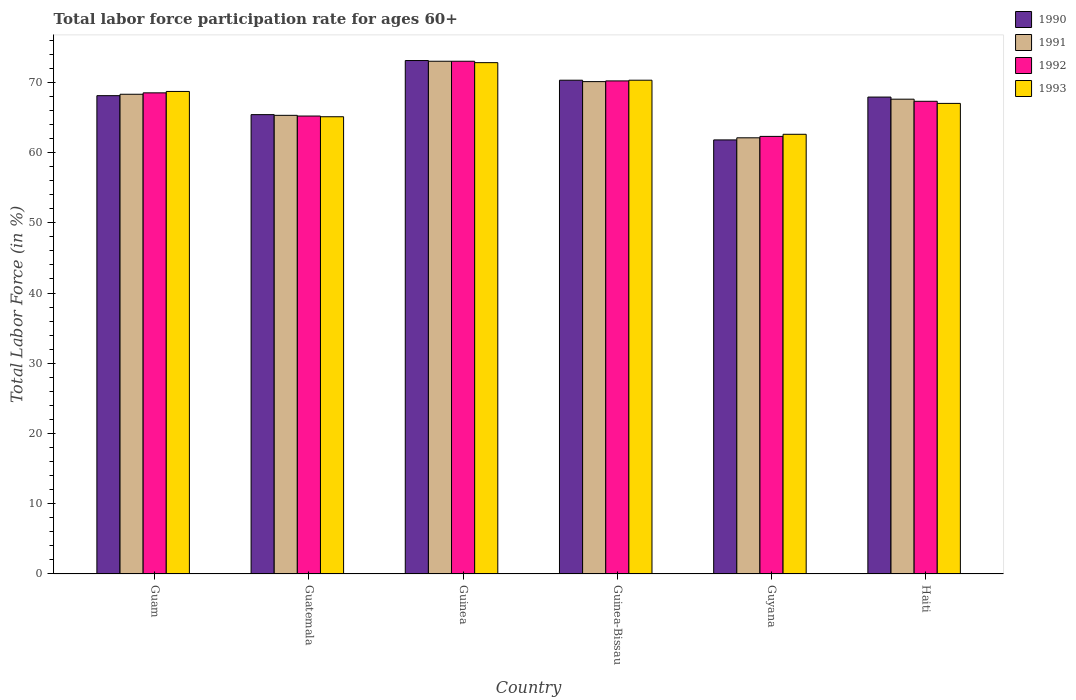How many groups of bars are there?
Your answer should be compact. 6. Are the number of bars on each tick of the X-axis equal?
Ensure brevity in your answer.  Yes. How many bars are there on the 6th tick from the left?
Provide a short and direct response. 4. How many bars are there on the 3rd tick from the right?
Your response must be concise. 4. What is the label of the 2nd group of bars from the left?
Your answer should be compact. Guatemala. What is the labor force participation rate in 1990 in Guyana?
Provide a succinct answer. 61.8. Across all countries, what is the minimum labor force participation rate in 1993?
Your answer should be very brief. 62.6. In which country was the labor force participation rate in 1991 maximum?
Your answer should be very brief. Guinea. In which country was the labor force participation rate in 1993 minimum?
Offer a terse response. Guyana. What is the total labor force participation rate in 1993 in the graph?
Your answer should be very brief. 406.5. What is the difference between the labor force participation rate in 1990 in Guatemala and that in Guyana?
Your answer should be compact. 3.6. What is the difference between the labor force participation rate in 1993 in Guyana and the labor force participation rate in 1990 in Guinea-Bissau?
Make the answer very short. -7.7. What is the average labor force participation rate in 1992 per country?
Your response must be concise. 67.75. What is the difference between the labor force participation rate of/in 1993 and labor force participation rate of/in 1991 in Guam?
Provide a short and direct response. 0.4. What is the ratio of the labor force participation rate in 1990 in Guam to that in Guatemala?
Provide a short and direct response. 1.04. Is the labor force participation rate in 1992 in Guatemala less than that in Guinea-Bissau?
Offer a terse response. Yes. Is the difference between the labor force participation rate in 1993 in Guam and Guatemala greater than the difference between the labor force participation rate in 1991 in Guam and Guatemala?
Provide a short and direct response. Yes. What is the difference between the highest and the second highest labor force participation rate in 1993?
Your answer should be compact. 4.1. What is the difference between the highest and the lowest labor force participation rate in 1992?
Offer a very short reply. 10.7. Is the sum of the labor force participation rate in 1990 in Guinea and Guinea-Bissau greater than the maximum labor force participation rate in 1991 across all countries?
Your answer should be very brief. Yes. Is it the case that in every country, the sum of the labor force participation rate in 1993 and labor force participation rate in 1991 is greater than the sum of labor force participation rate in 1990 and labor force participation rate in 1992?
Keep it short and to the point. No. What does the 4th bar from the left in Guam represents?
Ensure brevity in your answer.  1993. What does the 2nd bar from the right in Guyana represents?
Your response must be concise. 1992. Is it the case that in every country, the sum of the labor force participation rate in 1992 and labor force participation rate in 1991 is greater than the labor force participation rate in 1993?
Provide a succinct answer. Yes. How many bars are there?
Provide a short and direct response. 24. Are all the bars in the graph horizontal?
Your answer should be very brief. No. How many countries are there in the graph?
Provide a short and direct response. 6. What is the difference between two consecutive major ticks on the Y-axis?
Provide a short and direct response. 10. Where does the legend appear in the graph?
Make the answer very short. Top right. How many legend labels are there?
Make the answer very short. 4. What is the title of the graph?
Ensure brevity in your answer.  Total labor force participation rate for ages 60+. Does "1975" appear as one of the legend labels in the graph?
Give a very brief answer. No. What is the label or title of the Y-axis?
Make the answer very short. Total Labor Force (in %). What is the Total Labor Force (in %) of 1990 in Guam?
Keep it short and to the point. 68.1. What is the Total Labor Force (in %) of 1991 in Guam?
Provide a short and direct response. 68.3. What is the Total Labor Force (in %) of 1992 in Guam?
Your response must be concise. 68.5. What is the Total Labor Force (in %) in 1993 in Guam?
Provide a short and direct response. 68.7. What is the Total Labor Force (in %) of 1990 in Guatemala?
Keep it short and to the point. 65.4. What is the Total Labor Force (in %) in 1991 in Guatemala?
Keep it short and to the point. 65.3. What is the Total Labor Force (in %) in 1992 in Guatemala?
Offer a terse response. 65.2. What is the Total Labor Force (in %) in 1993 in Guatemala?
Give a very brief answer. 65.1. What is the Total Labor Force (in %) of 1990 in Guinea?
Your answer should be compact. 73.1. What is the Total Labor Force (in %) of 1991 in Guinea?
Provide a short and direct response. 73. What is the Total Labor Force (in %) in 1993 in Guinea?
Your answer should be compact. 72.8. What is the Total Labor Force (in %) in 1990 in Guinea-Bissau?
Provide a short and direct response. 70.3. What is the Total Labor Force (in %) in 1991 in Guinea-Bissau?
Offer a terse response. 70.1. What is the Total Labor Force (in %) of 1992 in Guinea-Bissau?
Offer a terse response. 70.2. What is the Total Labor Force (in %) in 1993 in Guinea-Bissau?
Offer a very short reply. 70.3. What is the Total Labor Force (in %) in 1990 in Guyana?
Offer a terse response. 61.8. What is the Total Labor Force (in %) of 1991 in Guyana?
Offer a very short reply. 62.1. What is the Total Labor Force (in %) in 1992 in Guyana?
Keep it short and to the point. 62.3. What is the Total Labor Force (in %) of 1993 in Guyana?
Your answer should be very brief. 62.6. What is the Total Labor Force (in %) of 1990 in Haiti?
Offer a terse response. 67.9. What is the Total Labor Force (in %) of 1991 in Haiti?
Provide a short and direct response. 67.6. What is the Total Labor Force (in %) in 1992 in Haiti?
Make the answer very short. 67.3. Across all countries, what is the maximum Total Labor Force (in %) in 1990?
Provide a succinct answer. 73.1. Across all countries, what is the maximum Total Labor Force (in %) of 1991?
Offer a terse response. 73. Across all countries, what is the maximum Total Labor Force (in %) in 1992?
Make the answer very short. 73. Across all countries, what is the maximum Total Labor Force (in %) of 1993?
Give a very brief answer. 72.8. Across all countries, what is the minimum Total Labor Force (in %) in 1990?
Make the answer very short. 61.8. Across all countries, what is the minimum Total Labor Force (in %) of 1991?
Give a very brief answer. 62.1. Across all countries, what is the minimum Total Labor Force (in %) in 1992?
Your response must be concise. 62.3. Across all countries, what is the minimum Total Labor Force (in %) in 1993?
Offer a terse response. 62.6. What is the total Total Labor Force (in %) in 1990 in the graph?
Offer a terse response. 406.6. What is the total Total Labor Force (in %) in 1991 in the graph?
Give a very brief answer. 406.4. What is the total Total Labor Force (in %) in 1992 in the graph?
Make the answer very short. 406.5. What is the total Total Labor Force (in %) of 1993 in the graph?
Ensure brevity in your answer.  406.5. What is the difference between the Total Labor Force (in %) of 1991 in Guam and that in Guatemala?
Provide a short and direct response. 3. What is the difference between the Total Labor Force (in %) in 1993 in Guam and that in Guatemala?
Your answer should be compact. 3.6. What is the difference between the Total Labor Force (in %) of 1991 in Guam and that in Guinea-Bissau?
Your answer should be compact. -1.8. What is the difference between the Total Labor Force (in %) of 1991 in Guam and that in Guyana?
Provide a short and direct response. 6.2. What is the difference between the Total Labor Force (in %) of 1993 in Guam and that in Guyana?
Provide a succinct answer. 6.1. What is the difference between the Total Labor Force (in %) of 1990 in Guam and that in Haiti?
Ensure brevity in your answer.  0.2. What is the difference between the Total Labor Force (in %) of 1991 in Guam and that in Haiti?
Your answer should be very brief. 0.7. What is the difference between the Total Labor Force (in %) in 1993 in Guam and that in Haiti?
Keep it short and to the point. 1.7. What is the difference between the Total Labor Force (in %) of 1990 in Guatemala and that in Guinea?
Keep it short and to the point. -7.7. What is the difference between the Total Labor Force (in %) in 1993 in Guatemala and that in Guinea?
Ensure brevity in your answer.  -7.7. What is the difference between the Total Labor Force (in %) of 1990 in Guatemala and that in Guinea-Bissau?
Provide a succinct answer. -4.9. What is the difference between the Total Labor Force (in %) in 1991 in Guatemala and that in Guinea-Bissau?
Provide a succinct answer. -4.8. What is the difference between the Total Labor Force (in %) of 1992 in Guatemala and that in Guinea-Bissau?
Provide a succinct answer. -5. What is the difference between the Total Labor Force (in %) in 1993 in Guatemala and that in Guinea-Bissau?
Offer a terse response. -5.2. What is the difference between the Total Labor Force (in %) of 1990 in Guatemala and that in Guyana?
Keep it short and to the point. 3.6. What is the difference between the Total Labor Force (in %) of 1993 in Guatemala and that in Guyana?
Your answer should be very brief. 2.5. What is the difference between the Total Labor Force (in %) of 1990 in Guinea and that in Guinea-Bissau?
Provide a succinct answer. 2.8. What is the difference between the Total Labor Force (in %) of 1992 in Guinea and that in Guinea-Bissau?
Provide a succinct answer. 2.8. What is the difference between the Total Labor Force (in %) in 1993 in Guinea and that in Guinea-Bissau?
Provide a short and direct response. 2.5. What is the difference between the Total Labor Force (in %) of 1990 in Guinea and that in Guyana?
Make the answer very short. 11.3. What is the difference between the Total Labor Force (in %) of 1990 in Guinea and that in Haiti?
Your answer should be very brief. 5.2. What is the difference between the Total Labor Force (in %) in 1990 in Guinea-Bissau and that in Guyana?
Give a very brief answer. 8.5. What is the difference between the Total Labor Force (in %) in 1993 in Guinea-Bissau and that in Guyana?
Provide a succinct answer. 7.7. What is the difference between the Total Labor Force (in %) of 1990 in Guinea-Bissau and that in Haiti?
Keep it short and to the point. 2.4. What is the difference between the Total Labor Force (in %) of 1991 in Guyana and that in Haiti?
Provide a succinct answer. -5.5. What is the difference between the Total Labor Force (in %) in 1992 in Guam and the Total Labor Force (in %) in 1993 in Guatemala?
Offer a very short reply. 3.4. What is the difference between the Total Labor Force (in %) in 1990 in Guam and the Total Labor Force (in %) in 1991 in Guinea?
Provide a succinct answer. -4.9. What is the difference between the Total Labor Force (in %) in 1992 in Guam and the Total Labor Force (in %) in 1993 in Guinea-Bissau?
Make the answer very short. -1.8. What is the difference between the Total Labor Force (in %) in 1990 in Guam and the Total Labor Force (in %) in 1991 in Guyana?
Offer a terse response. 6. What is the difference between the Total Labor Force (in %) of 1990 in Guam and the Total Labor Force (in %) of 1993 in Guyana?
Your answer should be compact. 5.5. What is the difference between the Total Labor Force (in %) in 1991 in Guam and the Total Labor Force (in %) in 1992 in Guyana?
Your answer should be compact. 6. What is the difference between the Total Labor Force (in %) of 1991 in Guam and the Total Labor Force (in %) of 1993 in Guyana?
Keep it short and to the point. 5.7. What is the difference between the Total Labor Force (in %) of 1990 in Guam and the Total Labor Force (in %) of 1991 in Haiti?
Your answer should be compact. 0.5. What is the difference between the Total Labor Force (in %) of 1990 in Guam and the Total Labor Force (in %) of 1992 in Haiti?
Your answer should be very brief. 0.8. What is the difference between the Total Labor Force (in %) of 1990 in Guam and the Total Labor Force (in %) of 1993 in Haiti?
Keep it short and to the point. 1.1. What is the difference between the Total Labor Force (in %) of 1991 in Guam and the Total Labor Force (in %) of 1992 in Haiti?
Offer a very short reply. 1. What is the difference between the Total Labor Force (in %) in 1991 in Guam and the Total Labor Force (in %) in 1993 in Haiti?
Make the answer very short. 1.3. What is the difference between the Total Labor Force (in %) in 1992 in Guam and the Total Labor Force (in %) in 1993 in Haiti?
Your answer should be compact. 1.5. What is the difference between the Total Labor Force (in %) in 1991 in Guatemala and the Total Labor Force (in %) in 1992 in Guinea-Bissau?
Make the answer very short. -4.9. What is the difference between the Total Labor Force (in %) of 1992 in Guatemala and the Total Labor Force (in %) of 1993 in Guinea-Bissau?
Offer a terse response. -5.1. What is the difference between the Total Labor Force (in %) of 1990 in Guatemala and the Total Labor Force (in %) of 1991 in Guyana?
Keep it short and to the point. 3.3. What is the difference between the Total Labor Force (in %) in 1990 in Guatemala and the Total Labor Force (in %) in 1992 in Guyana?
Ensure brevity in your answer.  3.1. What is the difference between the Total Labor Force (in %) of 1990 in Guatemala and the Total Labor Force (in %) of 1993 in Guyana?
Ensure brevity in your answer.  2.8. What is the difference between the Total Labor Force (in %) in 1990 in Guatemala and the Total Labor Force (in %) in 1992 in Haiti?
Give a very brief answer. -1.9. What is the difference between the Total Labor Force (in %) in 1990 in Guatemala and the Total Labor Force (in %) in 1993 in Haiti?
Your answer should be compact. -1.6. What is the difference between the Total Labor Force (in %) of 1991 in Guatemala and the Total Labor Force (in %) of 1993 in Haiti?
Keep it short and to the point. -1.7. What is the difference between the Total Labor Force (in %) in 1990 in Guinea and the Total Labor Force (in %) in 1992 in Guinea-Bissau?
Give a very brief answer. 2.9. What is the difference between the Total Labor Force (in %) of 1992 in Guinea and the Total Labor Force (in %) of 1993 in Guinea-Bissau?
Offer a terse response. 2.7. What is the difference between the Total Labor Force (in %) in 1990 in Guinea and the Total Labor Force (in %) in 1991 in Guyana?
Keep it short and to the point. 11. What is the difference between the Total Labor Force (in %) in 1990 in Guinea and the Total Labor Force (in %) in 1993 in Guyana?
Ensure brevity in your answer.  10.5. What is the difference between the Total Labor Force (in %) in 1991 in Guinea and the Total Labor Force (in %) in 1992 in Guyana?
Your response must be concise. 10.7. What is the difference between the Total Labor Force (in %) in 1991 in Guinea and the Total Labor Force (in %) in 1993 in Guyana?
Ensure brevity in your answer.  10.4. What is the difference between the Total Labor Force (in %) in 1990 in Guinea and the Total Labor Force (in %) in 1991 in Haiti?
Keep it short and to the point. 5.5. What is the difference between the Total Labor Force (in %) of 1991 in Guinea and the Total Labor Force (in %) of 1993 in Haiti?
Offer a terse response. 6. What is the difference between the Total Labor Force (in %) of 1990 in Guyana and the Total Labor Force (in %) of 1991 in Haiti?
Your answer should be compact. -5.8. What is the difference between the Total Labor Force (in %) in 1990 in Guyana and the Total Labor Force (in %) in 1993 in Haiti?
Your response must be concise. -5.2. What is the difference between the Total Labor Force (in %) in 1991 in Guyana and the Total Labor Force (in %) in 1993 in Haiti?
Offer a terse response. -4.9. What is the difference between the Total Labor Force (in %) in 1992 in Guyana and the Total Labor Force (in %) in 1993 in Haiti?
Ensure brevity in your answer.  -4.7. What is the average Total Labor Force (in %) in 1990 per country?
Provide a short and direct response. 67.77. What is the average Total Labor Force (in %) in 1991 per country?
Your response must be concise. 67.73. What is the average Total Labor Force (in %) in 1992 per country?
Your response must be concise. 67.75. What is the average Total Labor Force (in %) in 1993 per country?
Your answer should be compact. 67.75. What is the difference between the Total Labor Force (in %) of 1990 and Total Labor Force (in %) of 1992 in Guam?
Offer a very short reply. -0.4. What is the difference between the Total Labor Force (in %) in 1991 and Total Labor Force (in %) in 1993 in Guam?
Make the answer very short. -0.4. What is the difference between the Total Labor Force (in %) in 1990 and Total Labor Force (in %) in 1991 in Guatemala?
Provide a succinct answer. 0.1. What is the difference between the Total Labor Force (in %) in 1990 and Total Labor Force (in %) in 1991 in Guinea?
Your answer should be very brief. 0.1. What is the difference between the Total Labor Force (in %) in 1990 and Total Labor Force (in %) in 1992 in Guinea?
Keep it short and to the point. 0.1. What is the difference between the Total Labor Force (in %) in 1990 and Total Labor Force (in %) in 1993 in Guinea?
Your answer should be compact. 0.3. What is the difference between the Total Labor Force (in %) in 1992 and Total Labor Force (in %) in 1993 in Guinea?
Provide a succinct answer. 0.2. What is the difference between the Total Labor Force (in %) of 1990 and Total Labor Force (in %) of 1991 in Guinea-Bissau?
Offer a very short reply. 0.2. What is the difference between the Total Labor Force (in %) in 1990 and Total Labor Force (in %) in 1992 in Guinea-Bissau?
Provide a short and direct response. 0.1. What is the difference between the Total Labor Force (in %) in 1990 and Total Labor Force (in %) in 1993 in Guinea-Bissau?
Provide a short and direct response. 0. What is the difference between the Total Labor Force (in %) of 1991 and Total Labor Force (in %) of 1992 in Guinea-Bissau?
Offer a very short reply. -0.1. What is the difference between the Total Labor Force (in %) of 1991 and Total Labor Force (in %) of 1993 in Guinea-Bissau?
Make the answer very short. -0.2. What is the difference between the Total Labor Force (in %) in 1990 and Total Labor Force (in %) in 1992 in Guyana?
Your response must be concise. -0.5. What is the difference between the Total Labor Force (in %) in 1990 and Total Labor Force (in %) in 1993 in Guyana?
Provide a succinct answer. -0.8. What is the difference between the Total Labor Force (in %) of 1991 and Total Labor Force (in %) of 1992 in Guyana?
Your response must be concise. -0.2. What is the difference between the Total Labor Force (in %) of 1992 and Total Labor Force (in %) of 1993 in Guyana?
Ensure brevity in your answer.  -0.3. What is the difference between the Total Labor Force (in %) in 1991 and Total Labor Force (in %) in 1993 in Haiti?
Ensure brevity in your answer.  0.6. What is the ratio of the Total Labor Force (in %) of 1990 in Guam to that in Guatemala?
Ensure brevity in your answer.  1.04. What is the ratio of the Total Labor Force (in %) in 1991 in Guam to that in Guatemala?
Ensure brevity in your answer.  1.05. What is the ratio of the Total Labor Force (in %) of 1992 in Guam to that in Guatemala?
Provide a short and direct response. 1.05. What is the ratio of the Total Labor Force (in %) of 1993 in Guam to that in Guatemala?
Offer a terse response. 1.06. What is the ratio of the Total Labor Force (in %) of 1990 in Guam to that in Guinea?
Your response must be concise. 0.93. What is the ratio of the Total Labor Force (in %) of 1991 in Guam to that in Guinea?
Provide a succinct answer. 0.94. What is the ratio of the Total Labor Force (in %) in 1992 in Guam to that in Guinea?
Offer a very short reply. 0.94. What is the ratio of the Total Labor Force (in %) in 1993 in Guam to that in Guinea?
Your response must be concise. 0.94. What is the ratio of the Total Labor Force (in %) in 1990 in Guam to that in Guinea-Bissau?
Offer a terse response. 0.97. What is the ratio of the Total Labor Force (in %) in 1991 in Guam to that in Guinea-Bissau?
Offer a very short reply. 0.97. What is the ratio of the Total Labor Force (in %) of 1992 in Guam to that in Guinea-Bissau?
Provide a short and direct response. 0.98. What is the ratio of the Total Labor Force (in %) of 1993 in Guam to that in Guinea-Bissau?
Provide a short and direct response. 0.98. What is the ratio of the Total Labor Force (in %) of 1990 in Guam to that in Guyana?
Your answer should be compact. 1.1. What is the ratio of the Total Labor Force (in %) in 1991 in Guam to that in Guyana?
Provide a short and direct response. 1.1. What is the ratio of the Total Labor Force (in %) of 1992 in Guam to that in Guyana?
Provide a short and direct response. 1.1. What is the ratio of the Total Labor Force (in %) in 1993 in Guam to that in Guyana?
Make the answer very short. 1.1. What is the ratio of the Total Labor Force (in %) in 1990 in Guam to that in Haiti?
Make the answer very short. 1. What is the ratio of the Total Labor Force (in %) in 1991 in Guam to that in Haiti?
Your answer should be very brief. 1.01. What is the ratio of the Total Labor Force (in %) of 1992 in Guam to that in Haiti?
Offer a terse response. 1.02. What is the ratio of the Total Labor Force (in %) of 1993 in Guam to that in Haiti?
Make the answer very short. 1.03. What is the ratio of the Total Labor Force (in %) in 1990 in Guatemala to that in Guinea?
Make the answer very short. 0.89. What is the ratio of the Total Labor Force (in %) of 1991 in Guatemala to that in Guinea?
Offer a terse response. 0.89. What is the ratio of the Total Labor Force (in %) in 1992 in Guatemala to that in Guinea?
Offer a terse response. 0.89. What is the ratio of the Total Labor Force (in %) in 1993 in Guatemala to that in Guinea?
Your answer should be compact. 0.89. What is the ratio of the Total Labor Force (in %) in 1990 in Guatemala to that in Guinea-Bissau?
Provide a short and direct response. 0.93. What is the ratio of the Total Labor Force (in %) in 1991 in Guatemala to that in Guinea-Bissau?
Offer a very short reply. 0.93. What is the ratio of the Total Labor Force (in %) of 1992 in Guatemala to that in Guinea-Bissau?
Offer a terse response. 0.93. What is the ratio of the Total Labor Force (in %) in 1993 in Guatemala to that in Guinea-Bissau?
Provide a short and direct response. 0.93. What is the ratio of the Total Labor Force (in %) in 1990 in Guatemala to that in Guyana?
Offer a very short reply. 1.06. What is the ratio of the Total Labor Force (in %) in 1991 in Guatemala to that in Guyana?
Provide a short and direct response. 1.05. What is the ratio of the Total Labor Force (in %) of 1992 in Guatemala to that in Guyana?
Provide a short and direct response. 1.05. What is the ratio of the Total Labor Force (in %) in 1993 in Guatemala to that in Guyana?
Your answer should be compact. 1.04. What is the ratio of the Total Labor Force (in %) in 1990 in Guatemala to that in Haiti?
Offer a terse response. 0.96. What is the ratio of the Total Labor Force (in %) in 1991 in Guatemala to that in Haiti?
Provide a succinct answer. 0.97. What is the ratio of the Total Labor Force (in %) of 1992 in Guatemala to that in Haiti?
Keep it short and to the point. 0.97. What is the ratio of the Total Labor Force (in %) in 1993 in Guatemala to that in Haiti?
Give a very brief answer. 0.97. What is the ratio of the Total Labor Force (in %) in 1990 in Guinea to that in Guinea-Bissau?
Your answer should be very brief. 1.04. What is the ratio of the Total Labor Force (in %) in 1991 in Guinea to that in Guinea-Bissau?
Make the answer very short. 1.04. What is the ratio of the Total Labor Force (in %) in 1992 in Guinea to that in Guinea-Bissau?
Provide a succinct answer. 1.04. What is the ratio of the Total Labor Force (in %) of 1993 in Guinea to that in Guinea-Bissau?
Ensure brevity in your answer.  1.04. What is the ratio of the Total Labor Force (in %) of 1990 in Guinea to that in Guyana?
Your response must be concise. 1.18. What is the ratio of the Total Labor Force (in %) of 1991 in Guinea to that in Guyana?
Offer a very short reply. 1.18. What is the ratio of the Total Labor Force (in %) in 1992 in Guinea to that in Guyana?
Keep it short and to the point. 1.17. What is the ratio of the Total Labor Force (in %) in 1993 in Guinea to that in Guyana?
Keep it short and to the point. 1.16. What is the ratio of the Total Labor Force (in %) in 1990 in Guinea to that in Haiti?
Make the answer very short. 1.08. What is the ratio of the Total Labor Force (in %) of 1991 in Guinea to that in Haiti?
Your answer should be very brief. 1.08. What is the ratio of the Total Labor Force (in %) of 1992 in Guinea to that in Haiti?
Give a very brief answer. 1.08. What is the ratio of the Total Labor Force (in %) in 1993 in Guinea to that in Haiti?
Offer a terse response. 1.09. What is the ratio of the Total Labor Force (in %) of 1990 in Guinea-Bissau to that in Guyana?
Your response must be concise. 1.14. What is the ratio of the Total Labor Force (in %) of 1991 in Guinea-Bissau to that in Guyana?
Offer a terse response. 1.13. What is the ratio of the Total Labor Force (in %) of 1992 in Guinea-Bissau to that in Guyana?
Give a very brief answer. 1.13. What is the ratio of the Total Labor Force (in %) in 1993 in Guinea-Bissau to that in Guyana?
Offer a terse response. 1.12. What is the ratio of the Total Labor Force (in %) in 1990 in Guinea-Bissau to that in Haiti?
Your answer should be very brief. 1.04. What is the ratio of the Total Labor Force (in %) in 1992 in Guinea-Bissau to that in Haiti?
Your answer should be compact. 1.04. What is the ratio of the Total Labor Force (in %) in 1993 in Guinea-Bissau to that in Haiti?
Offer a very short reply. 1.05. What is the ratio of the Total Labor Force (in %) in 1990 in Guyana to that in Haiti?
Make the answer very short. 0.91. What is the ratio of the Total Labor Force (in %) in 1991 in Guyana to that in Haiti?
Ensure brevity in your answer.  0.92. What is the ratio of the Total Labor Force (in %) in 1992 in Guyana to that in Haiti?
Offer a very short reply. 0.93. What is the ratio of the Total Labor Force (in %) of 1993 in Guyana to that in Haiti?
Offer a terse response. 0.93. What is the difference between the highest and the second highest Total Labor Force (in %) of 1993?
Ensure brevity in your answer.  2.5. What is the difference between the highest and the lowest Total Labor Force (in %) of 1990?
Provide a succinct answer. 11.3. What is the difference between the highest and the lowest Total Labor Force (in %) of 1991?
Offer a very short reply. 10.9. What is the difference between the highest and the lowest Total Labor Force (in %) of 1992?
Your answer should be very brief. 10.7. 